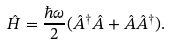Convert formula to latex. <formula><loc_0><loc_0><loc_500><loc_500>\hat { H } = \frac { \hbar { \omega } } { 2 } ( \hat { A } ^ { \dag } \hat { A } + \hat { A } \hat { A } ^ { \dag } ) .</formula> 